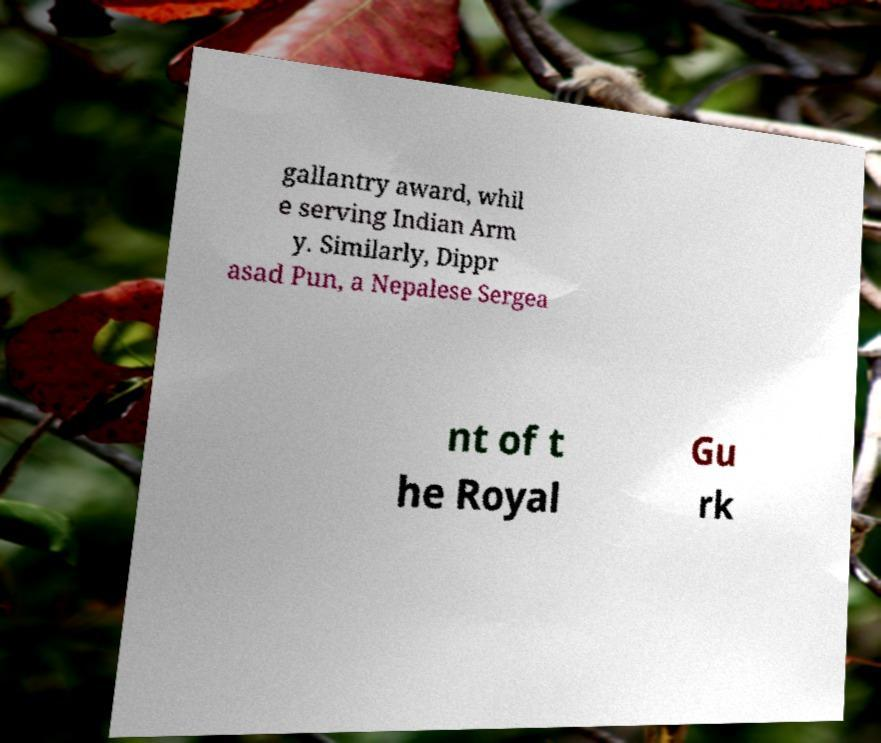Could you extract and type out the text from this image? gallantry award, whil e serving Indian Arm y. Similarly, Dippr asad Pun, a Nepalese Sergea nt of t he Royal Gu rk 